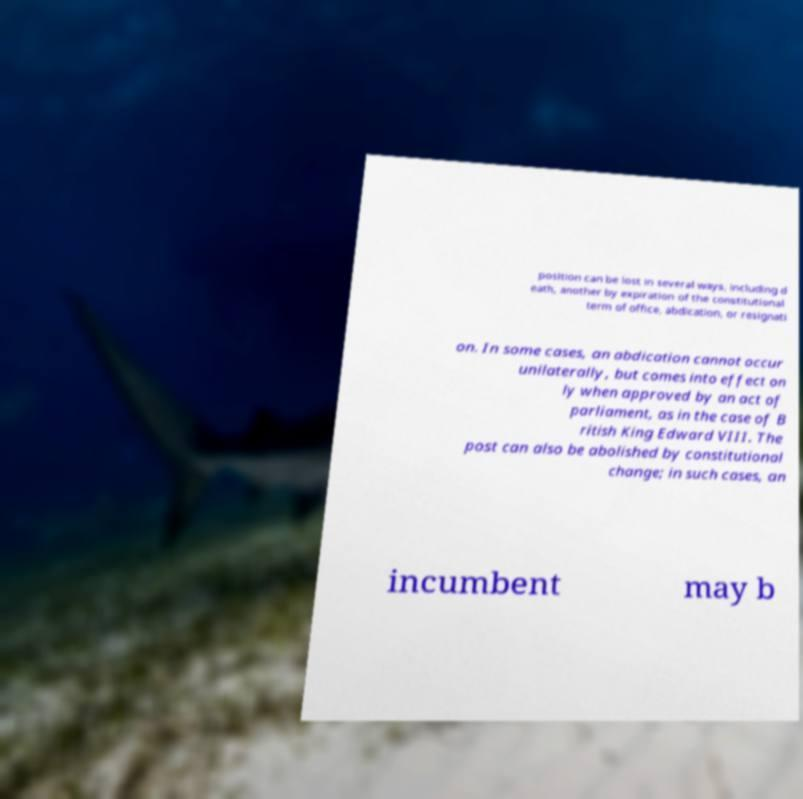I need the written content from this picture converted into text. Can you do that? position can be lost in several ways, including d eath, another by expiration of the constitutional term of office, abdication, or resignati on. In some cases, an abdication cannot occur unilaterally, but comes into effect on ly when approved by an act of parliament, as in the case of B ritish King Edward VIII. The post can also be abolished by constitutional change; in such cases, an incumbent may b 